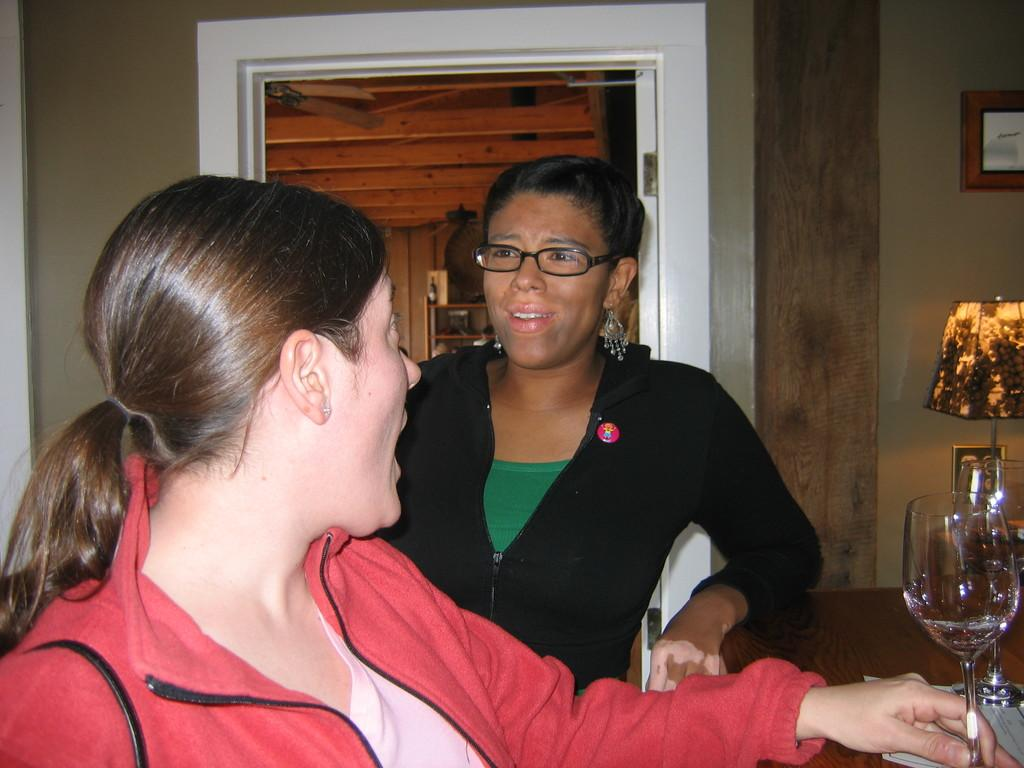How many people are in the image? There are two persons standing in the image. What can be seen in the image besides the people? There is a table, a glass, and a door visible in the image. What type of bread is being used to control the pest in the image? There is no bread or pest present in the image. What type of work are the people doing in the image? The provided facts do not indicate what type of work the people are doing in the image. 